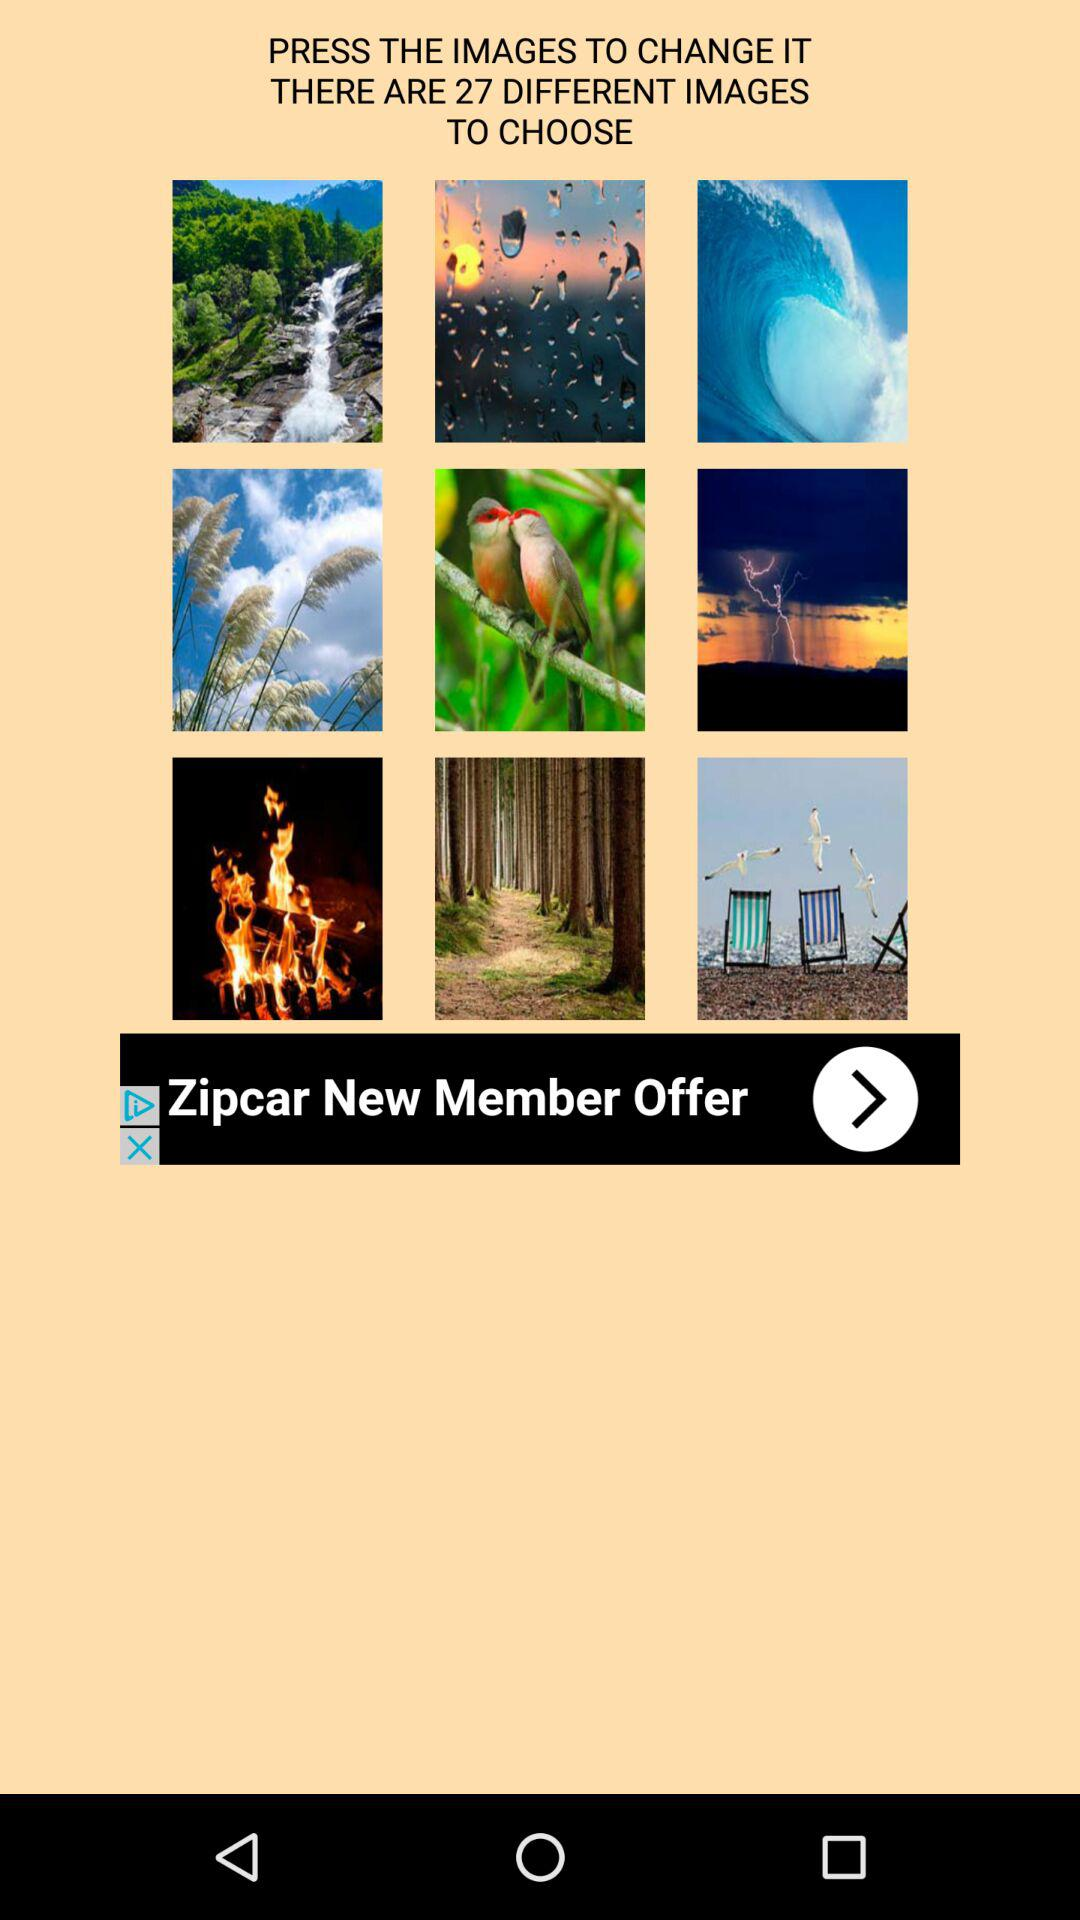Which photo did the user choose?
When the provided information is insufficient, respond with <no answer>. <no answer> 